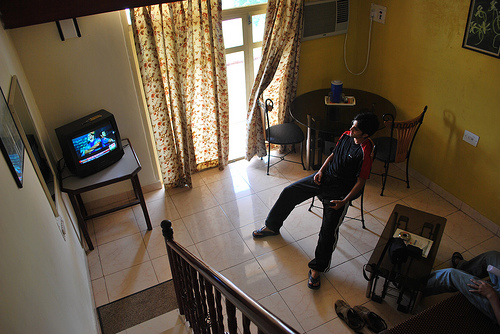Can you describe the interior design of the room shown in the image? The interior design of the room is simple and functional, with a warm color palette. There’s a television set on a small stand, a wooden coffee table, and a matching wooden railing around the staircase. The curtains have a floral pattern, which adds a touch of nature to the room. The lighting seems natural, likely from the balcony door, complementing the cozy ambiance. 